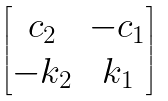Convert formula to latex. <formula><loc_0><loc_0><loc_500><loc_500>\begin{bmatrix} c _ { 2 } & - c _ { 1 } \\ - k _ { 2 } & k _ { 1 } \end{bmatrix}</formula> 